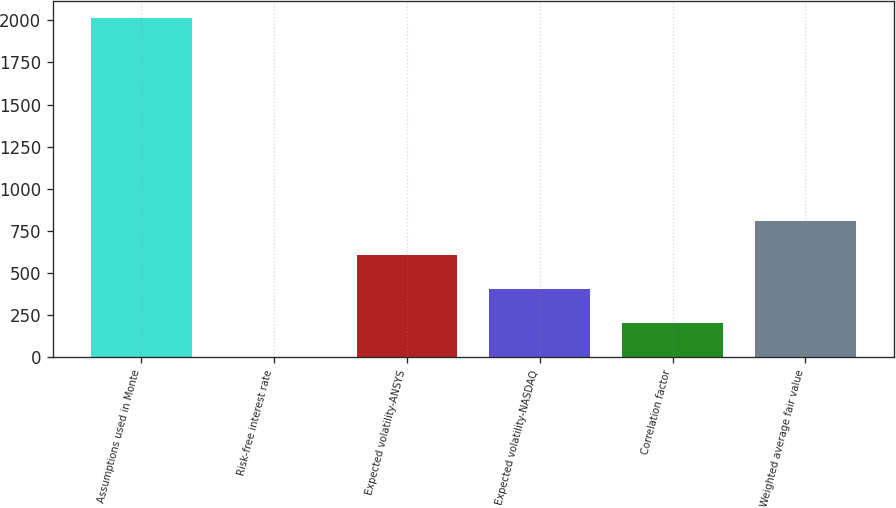<chart> <loc_0><loc_0><loc_500><loc_500><bar_chart><fcel>Assumptions used in Monte<fcel>Risk-free interest rate<fcel>Expected volatility-ANSYS<fcel>Expected volatility-NASDAQ<fcel>Correlation factor<fcel>Weighted average fair value<nl><fcel>2013<fcel>0.35<fcel>604.14<fcel>402.88<fcel>201.62<fcel>805.4<nl></chart> 